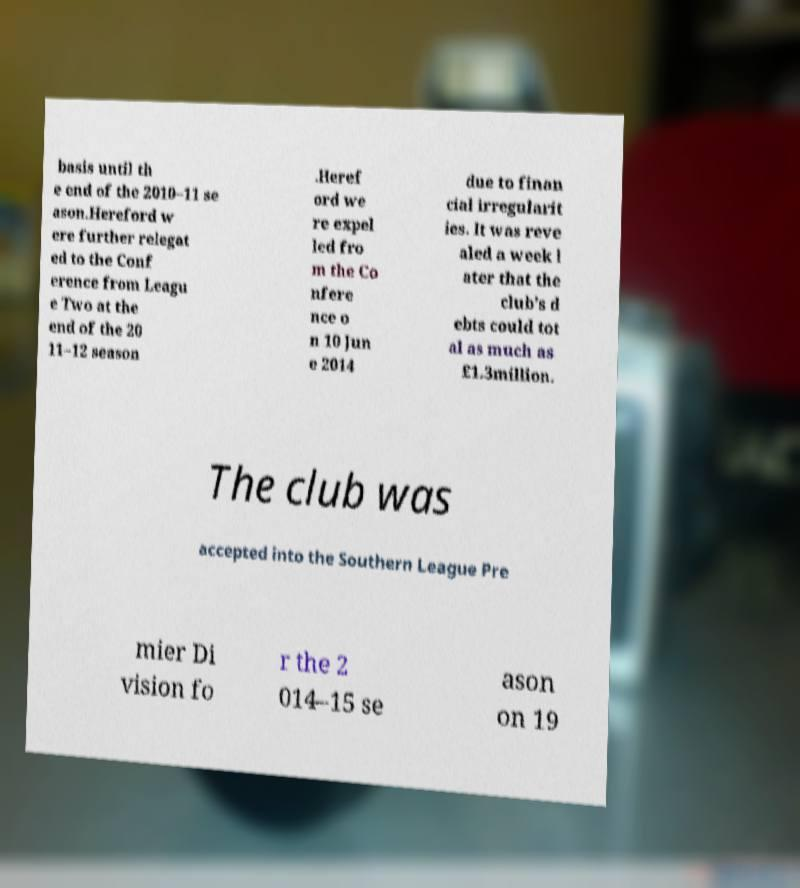Could you extract and type out the text from this image? basis until th e end of the 2010–11 se ason.Hereford w ere further relegat ed to the Conf erence from Leagu e Two at the end of the 20 11–12 season .Heref ord we re expel led fro m the Co nfere nce o n 10 Jun e 2014 due to finan cial irregularit ies. It was reve aled a week l ater that the club's d ebts could tot al as much as £1.3million. The club was accepted into the Southern League Pre mier Di vision fo r the 2 014–15 se ason on 19 